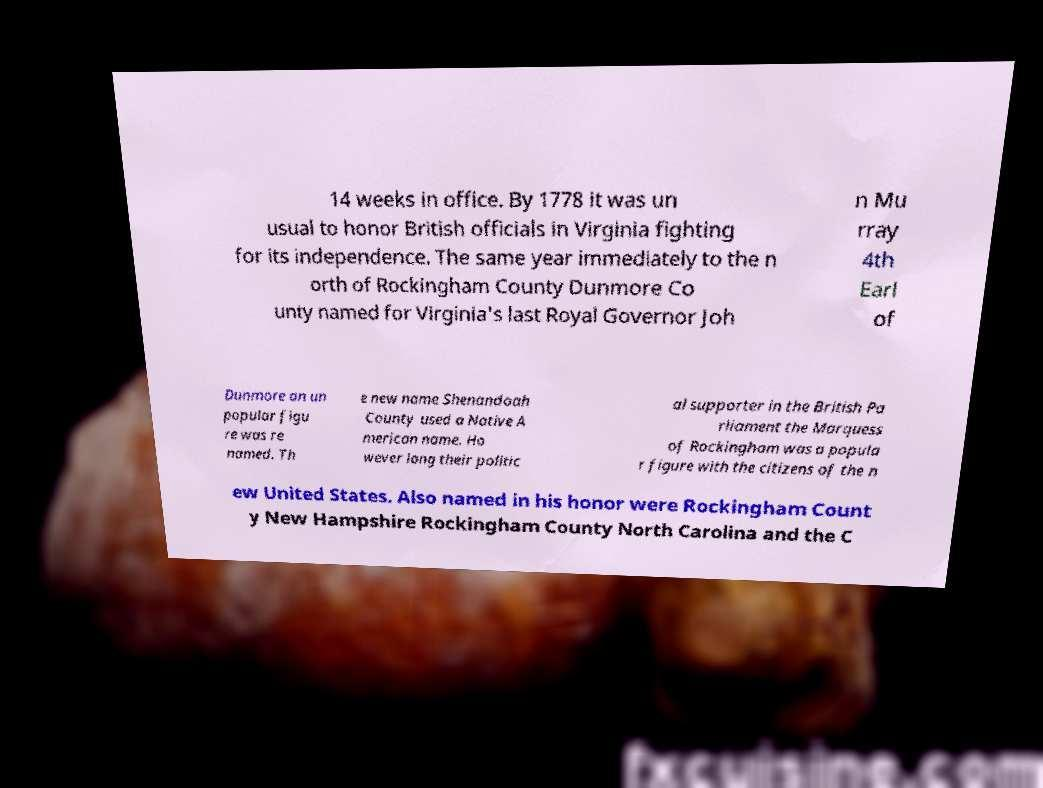Could you assist in decoding the text presented in this image and type it out clearly? 14 weeks in office. By 1778 it was un usual to honor British officials in Virginia fighting for its independence. The same year immediately to the n orth of Rockingham County Dunmore Co unty named for Virginia's last Royal Governor Joh n Mu rray 4th Earl of Dunmore an un popular figu re was re named. Th e new name Shenandoah County used a Native A merican name. Ho wever long their politic al supporter in the British Pa rliament the Marquess of Rockingham was a popula r figure with the citizens of the n ew United States. Also named in his honor were Rockingham Count y New Hampshire Rockingham County North Carolina and the C 